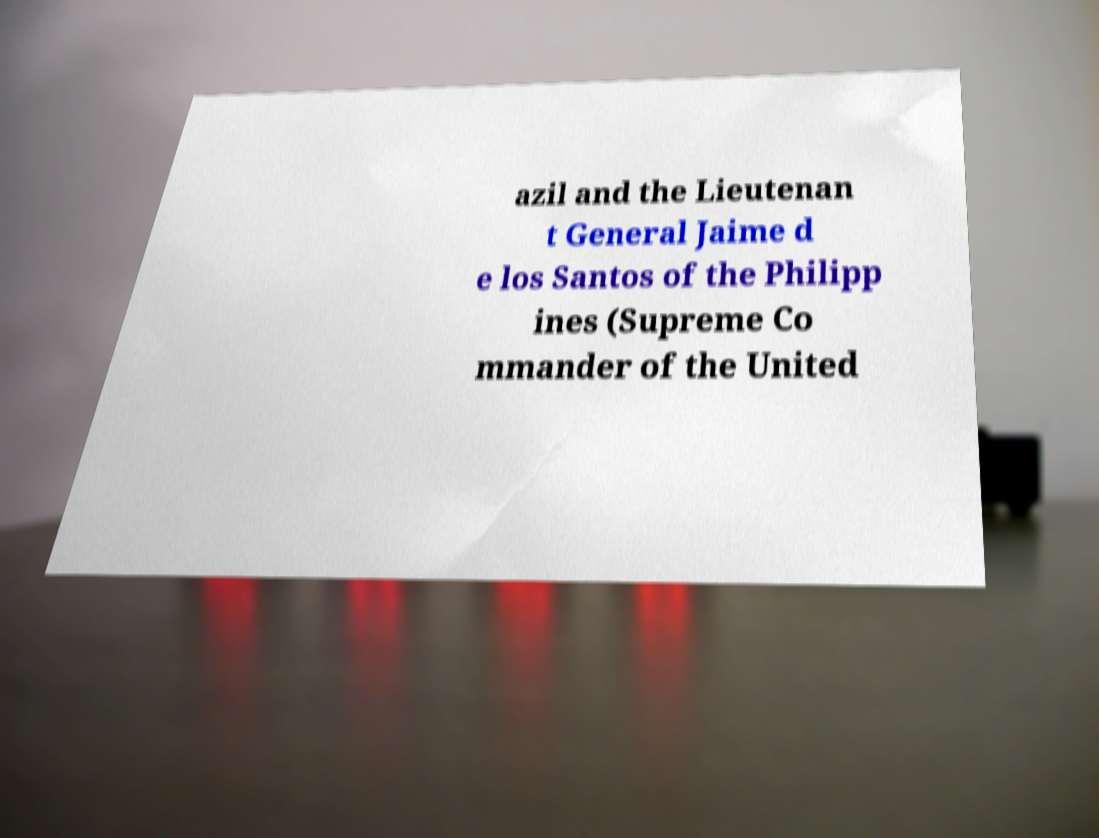Please read and relay the text visible in this image. What does it say? azil and the Lieutenan t General Jaime d e los Santos of the Philipp ines (Supreme Co mmander of the United 